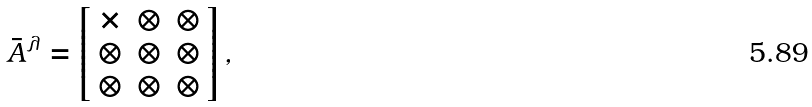Convert formula to latex. <formula><loc_0><loc_0><loc_500><loc_500>\bar { A } ^ { \lambda } = \left [ \begin{array} { c c c } \times & \otimes & \otimes \\ \otimes & \otimes & \otimes \\ \otimes & \otimes & \otimes \end{array} \right ] ,</formula> 